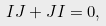<formula> <loc_0><loc_0><loc_500><loc_500>I J + J I = 0 ,</formula> 